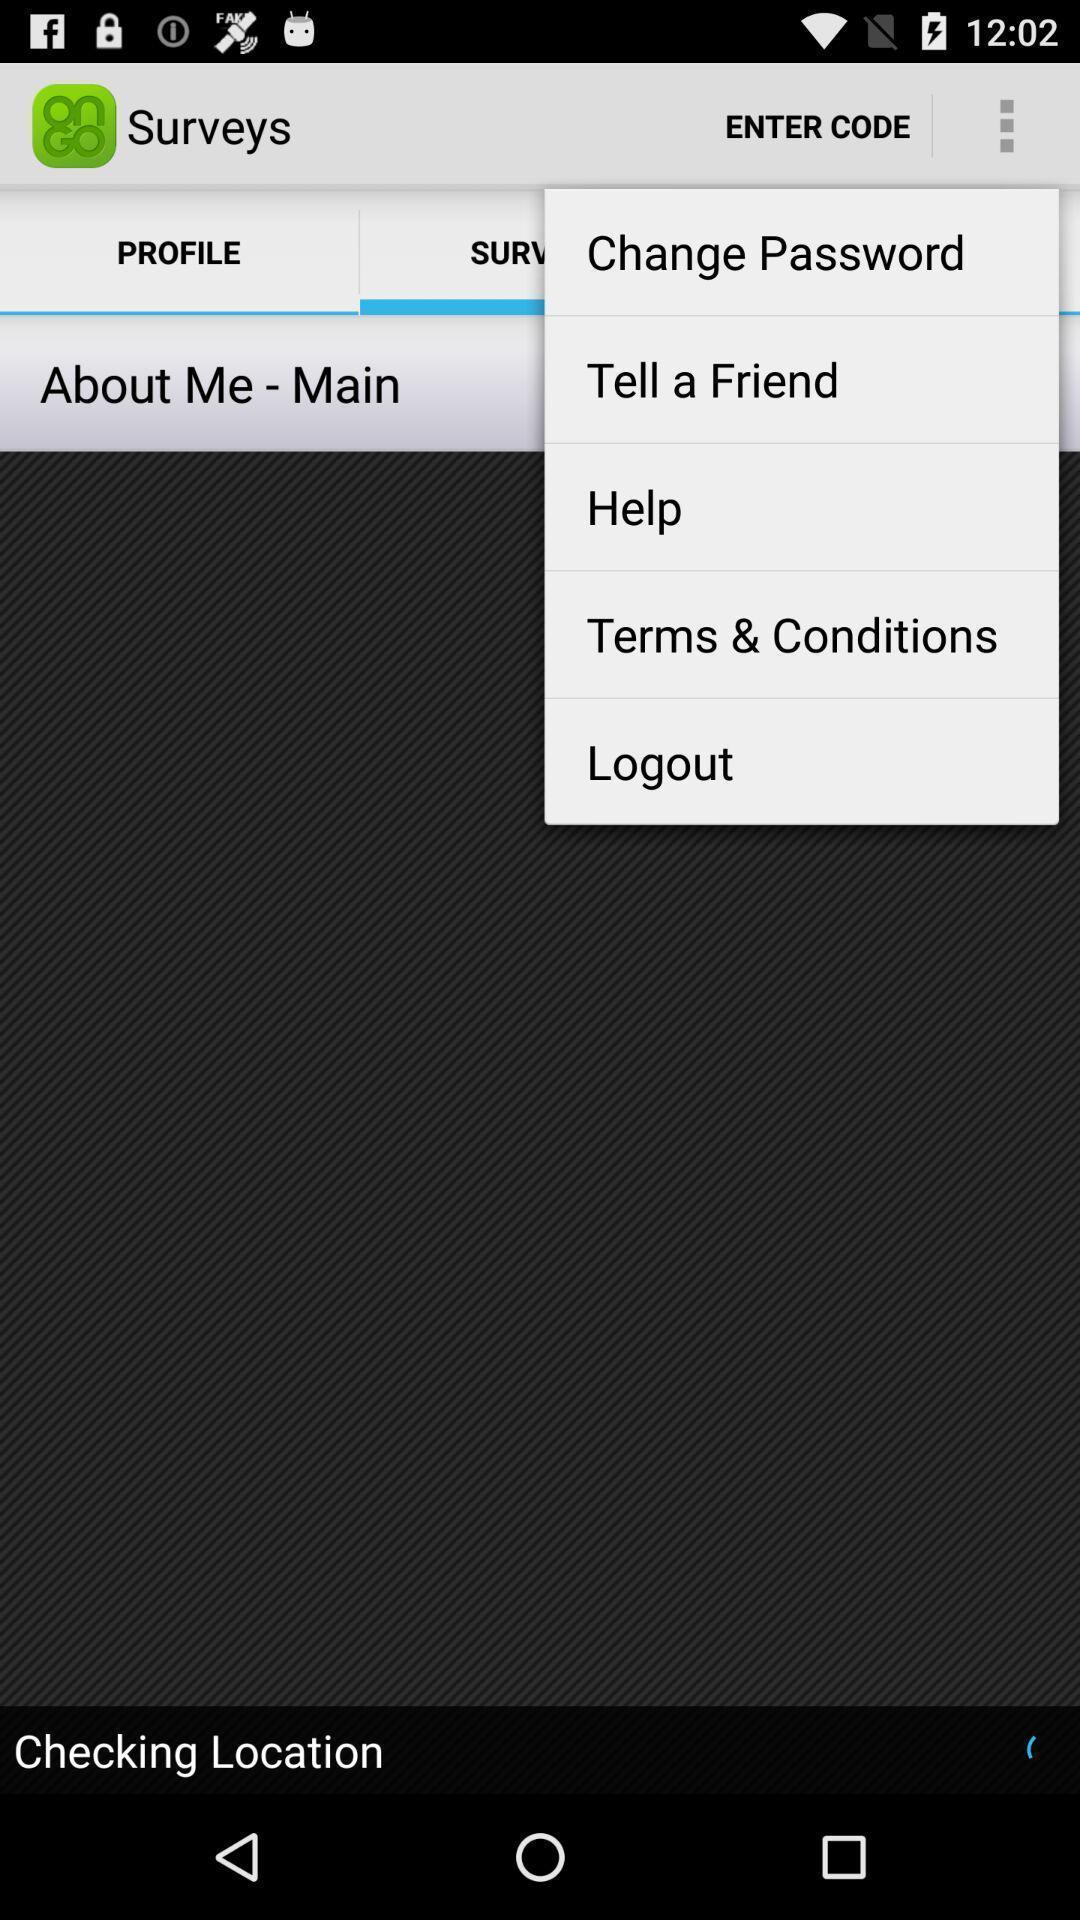Provide a detailed account of this screenshot. Various options page in a survey app. 